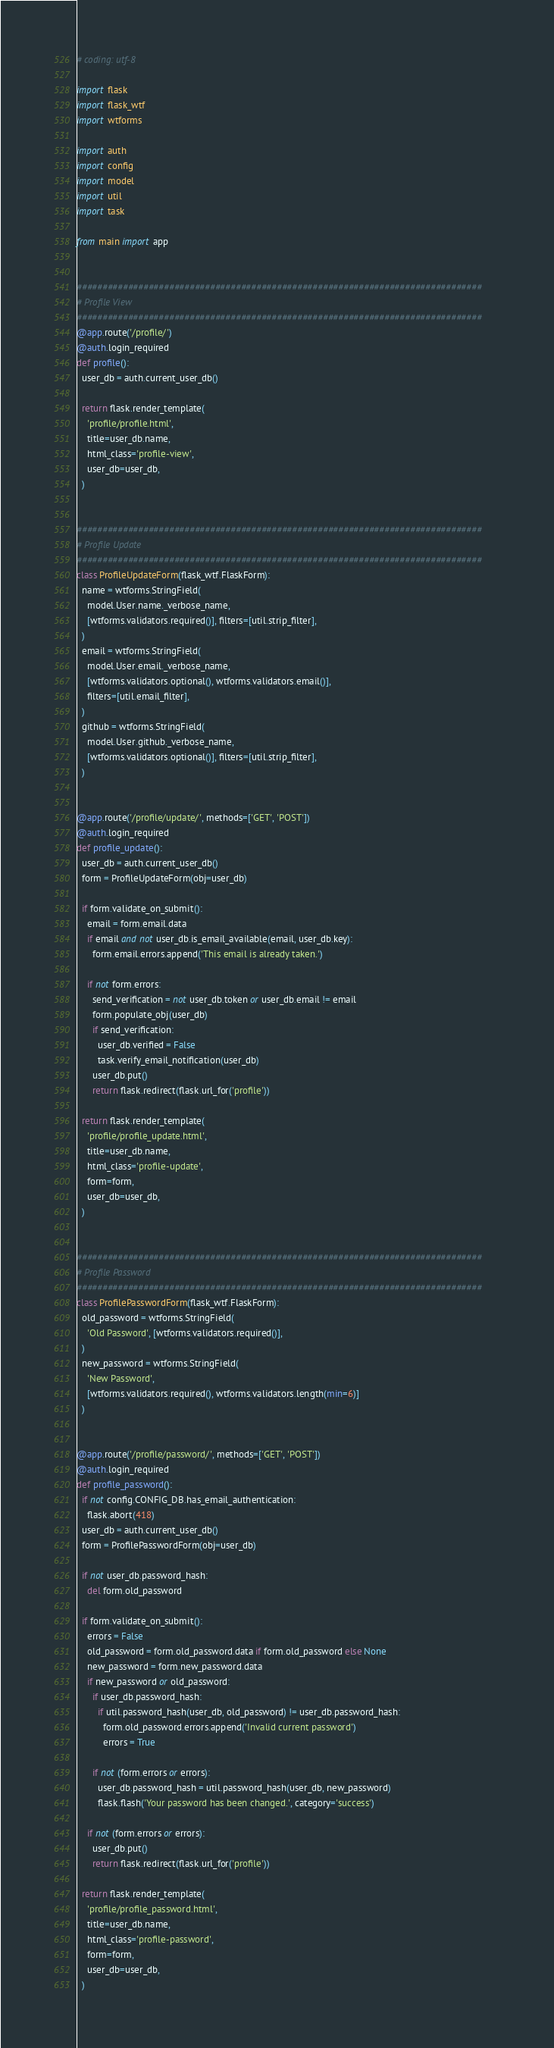Convert code to text. <code><loc_0><loc_0><loc_500><loc_500><_Python_># coding: utf-8

import flask
import flask_wtf
import wtforms

import auth
import config
import model
import util
import task

from main import app


###############################################################################
# Profile View
###############################################################################
@app.route('/profile/')
@auth.login_required
def profile():
  user_db = auth.current_user_db()

  return flask.render_template(
    'profile/profile.html',
    title=user_db.name,
    html_class='profile-view',
    user_db=user_db,
  )


###############################################################################
# Profile Update
###############################################################################
class ProfileUpdateForm(flask_wtf.FlaskForm):
  name = wtforms.StringField(
    model.User.name._verbose_name,
    [wtforms.validators.required()], filters=[util.strip_filter],
  )
  email = wtforms.StringField(
    model.User.email._verbose_name,
    [wtforms.validators.optional(), wtforms.validators.email()],
    filters=[util.email_filter],
  )
  github = wtforms.StringField(
    model.User.github._verbose_name,
    [wtforms.validators.optional()], filters=[util.strip_filter],
  )


@app.route('/profile/update/', methods=['GET', 'POST'])
@auth.login_required
def profile_update():
  user_db = auth.current_user_db()
  form = ProfileUpdateForm(obj=user_db)

  if form.validate_on_submit():
    email = form.email.data
    if email and not user_db.is_email_available(email, user_db.key):
      form.email.errors.append('This email is already taken.')

    if not form.errors:
      send_verification = not user_db.token or user_db.email != email
      form.populate_obj(user_db)
      if send_verification:
        user_db.verified = False
        task.verify_email_notification(user_db)
      user_db.put()
      return flask.redirect(flask.url_for('profile'))

  return flask.render_template(
    'profile/profile_update.html',
    title=user_db.name,
    html_class='profile-update',
    form=form,
    user_db=user_db,
  )


###############################################################################
# Profile Password
###############################################################################
class ProfilePasswordForm(flask_wtf.FlaskForm):
  old_password = wtforms.StringField(
    'Old Password', [wtforms.validators.required()],
  )
  new_password = wtforms.StringField(
    'New Password',
    [wtforms.validators.required(), wtforms.validators.length(min=6)]
  )


@app.route('/profile/password/', methods=['GET', 'POST'])
@auth.login_required
def profile_password():
  if not config.CONFIG_DB.has_email_authentication:
    flask.abort(418)
  user_db = auth.current_user_db()
  form = ProfilePasswordForm(obj=user_db)

  if not user_db.password_hash:
    del form.old_password

  if form.validate_on_submit():
    errors = False
    old_password = form.old_password.data if form.old_password else None
    new_password = form.new_password.data
    if new_password or old_password:
      if user_db.password_hash:
        if util.password_hash(user_db, old_password) != user_db.password_hash:
          form.old_password.errors.append('Invalid current password')
          errors = True

      if not (form.errors or errors):
        user_db.password_hash = util.password_hash(user_db, new_password)
        flask.flash('Your password has been changed.', category='success')

    if not (form.errors or errors):
      user_db.put()
      return flask.redirect(flask.url_for('profile'))

  return flask.render_template(
    'profile/profile_password.html',
    title=user_db.name,
    html_class='profile-password',
    form=form,
    user_db=user_db,
  )
</code> 